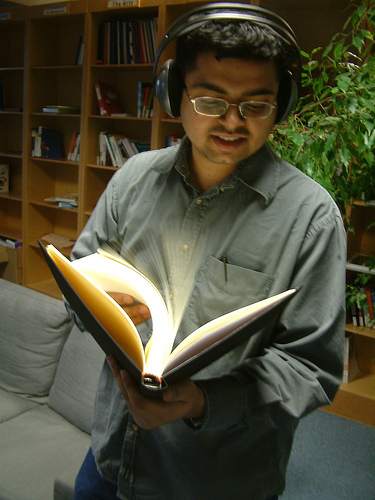<image>
Can you confirm if the book is on the man? Yes. Looking at the image, I can see the book is positioned on top of the man, with the man providing support. Is there a plant behind the man? Yes. From this viewpoint, the plant is positioned behind the man, with the man partially or fully occluding the plant. 